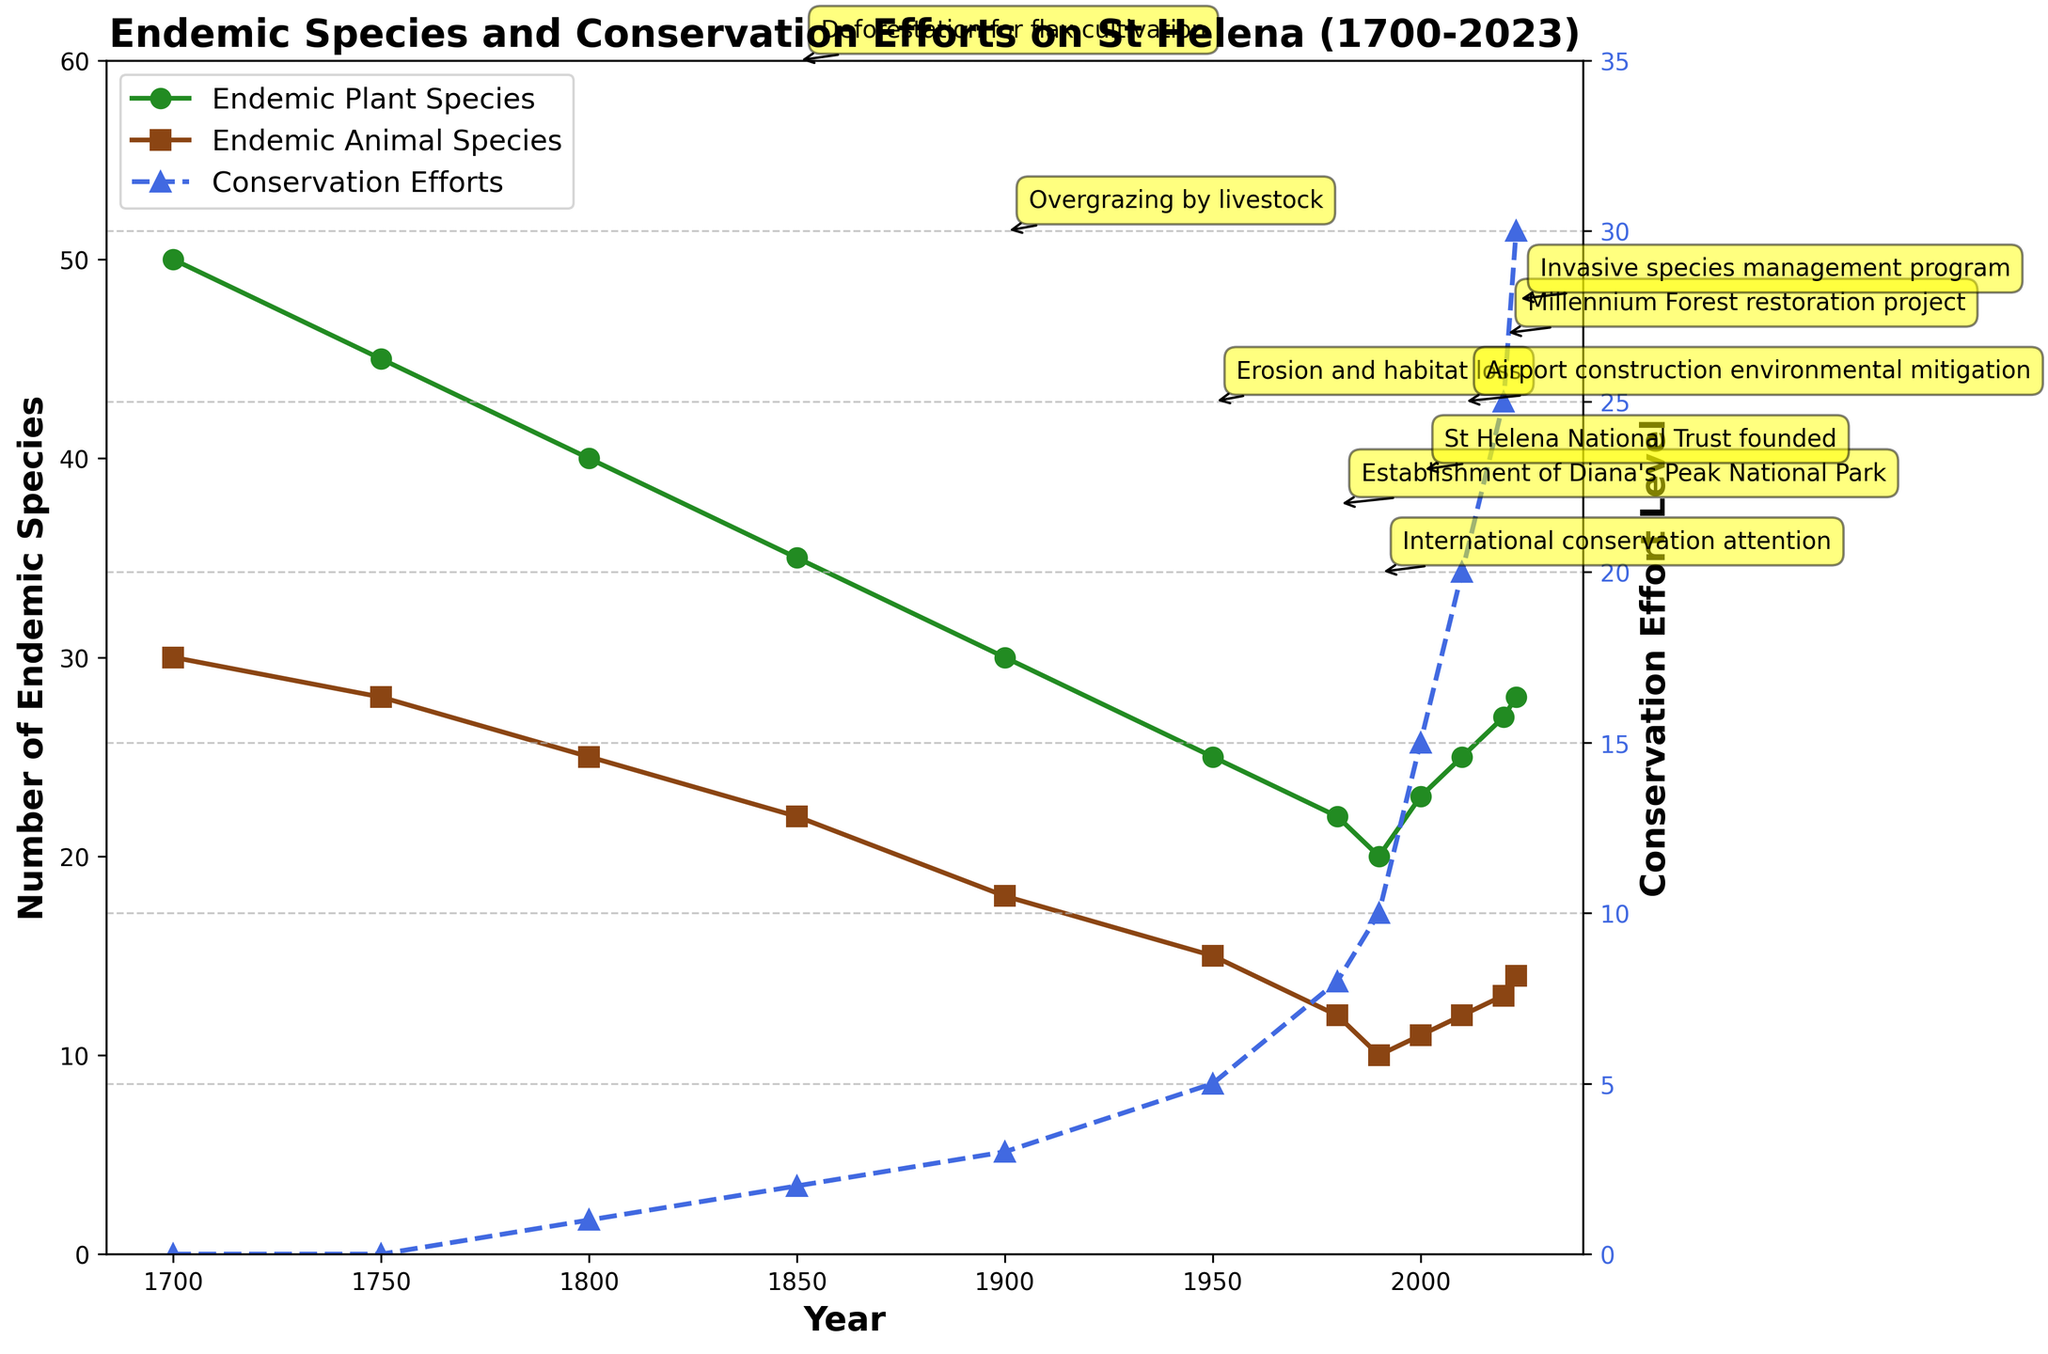What was the number of endemic plant species in 1900? According to the figure, the number of endemic plant species in 1900 is shown on the green line. Looking at this point on the x-axis (Year 1900) aligns vertically with the y-axis value of around 30.
Answer: 30 In what year did conservation efforts reach level 15? The blue line with triangles represents conservation efforts. By finding the point where the y-axis value of this line is 15, trace vertically to the x-axis to find the corresponding year, which is 2000.
Answer: 2000 By how many species did the number of endemic plant species increase between 2000 and 2020? From the figure, the number of endemic plant species in 2000 is about 23, and in 2020 it is about 27. The increase is calculated by subtracting the former from the latter (27 - 23 = 4).
Answer: 4 Which had a higher number in 1800: endemic plant species or endemic animal species, and by how much? In 1800, the figure shows about 40 endemic plant species (green line) and 25 endemic animal species (brown line). To find out how much higher the plant species number is, subtract the number of animal species from the number of plant species (40 - 25 = 15).
Answer: Endemic plant species by 15 When were the first major impacts on endemic species noted, and what were they? Annotations on the figure indicate major impacts. The first noted major impact, "Initial European settlement," is annotated at 1700.
Answer: 1700, Initial European settlement How did the number of endemic animal species change from 1750 to 1950? Looking at the brown line, the number of endemic animal species in 1750 is about 28 and in 1950 is about 15. The change is computed by subtracting the number in 1950 from the number in 1750 (28 - 15 = 13).
Answer: Decreased by 13 In which decade of the 20th century did conservation efforts show the most significant increase? The blue line with triangles marking the conservation efforts shows the steepest rise between two decades of the 20th century. From 1980 to 1990, the level of conservation efforts increased steeply.
Answer: 1980 to 1990 What is the total number of endemic plant species added from 2010 to 2023? From the figure, the number of endemic plant species in 2010 is 25 and in 2023 is 28. Calculate the total number added by subtracting the initial value from the final value (28 - 25 = 3).
Answer: 3 Which color line represents conservation efforts and what is its style? The figure shows conservation efforts represented by a blue dashed line with triangle markers.
Answer: Blue dashed line with triangles Did the establishment of Diana's Peak National Park correlate with an increase or decrease in the number of endemic animal species? The establishment of Diana's Peak National Park is annotated around 1980. Observing the brown line (endemic animal species), there is no immediate increase; the numbers slightly decrease or remain stable.
Answer: Stable/Decrease 